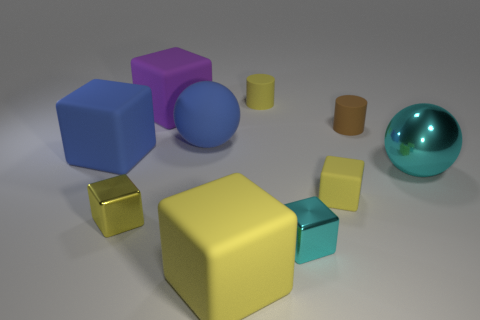Subtract all gray cylinders. How many yellow blocks are left? 3 Subtract all blue cubes. How many cubes are left? 5 Subtract all large purple blocks. How many blocks are left? 5 Subtract all blue blocks. Subtract all blue spheres. How many blocks are left? 5 Subtract all cylinders. How many objects are left? 8 Subtract all large things. Subtract all tiny yellow rubber cylinders. How many objects are left? 4 Add 7 shiny objects. How many shiny objects are left? 10 Add 9 blue metal blocks. How many blue metal blocks exist? 9 Subtract 0 purple cylinders. How many objects are left? 10 